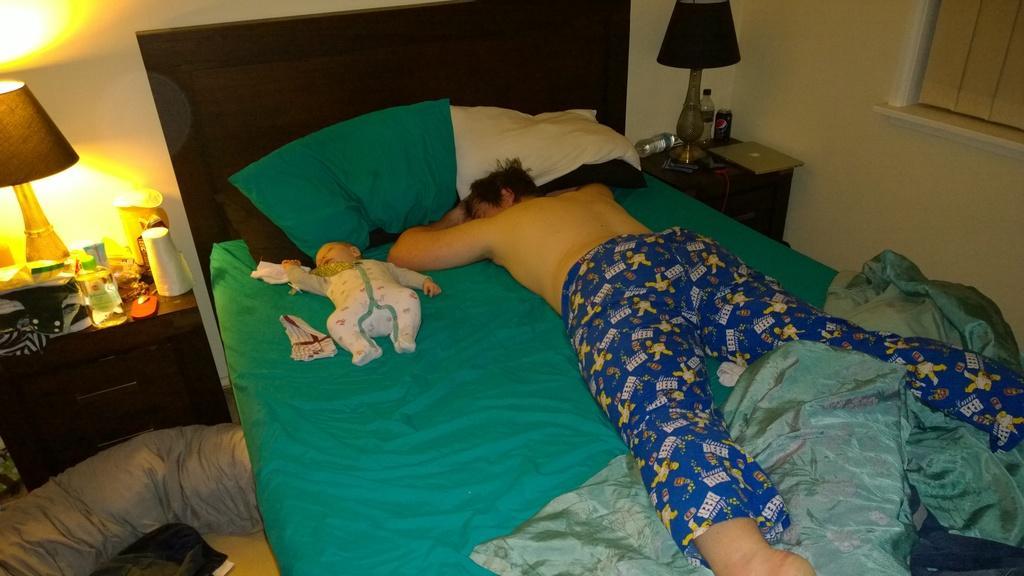Describe this image in one or two sentences. In the picture we can find a man sleeping on the bed with a baby. In the background we can find a table and lamp on it and some items. In the right side of picture we can find a window and a wall. On the bed we can find some pillows. 